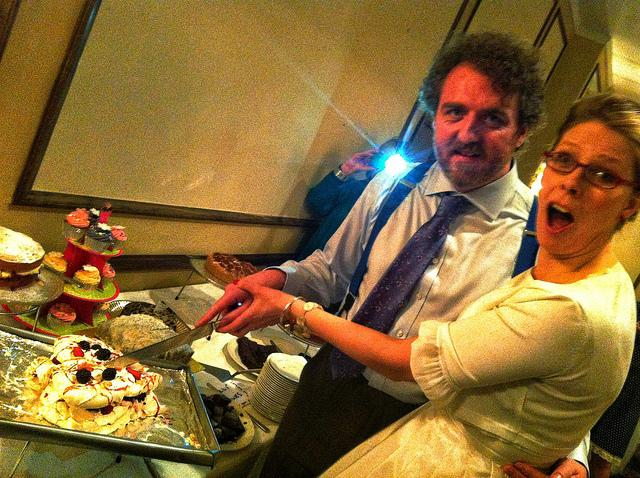Why is the man behind the other two holding a flashing object? taking picture 